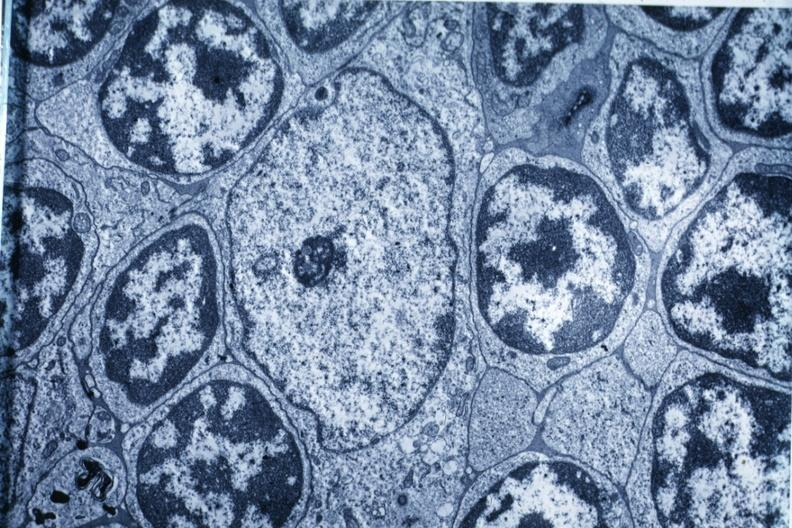what is present?
Answer the question using a single word or phrase. Thymoma 